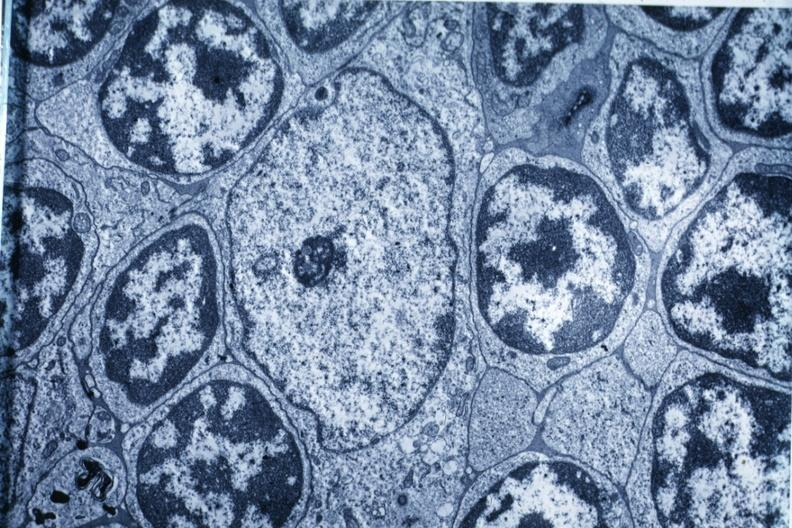what is present?
Answer the question using a single word or phrase. Thymoma 